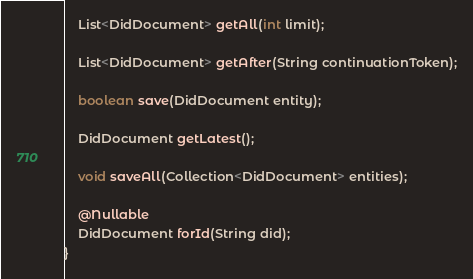<code> <loc_0><loc_0><loc_500><loc_500><_Java_>    List<DidDocument> getAll(int limit);

    List<DidDocument> getAfter(String continuationToken);

    boolean save(DidDocument entity);

    DidDocument getLatest();

    void saveAll(Collection<DidDocument> entities);

    @Nullable
    DidDocument forId(String did);
}
</code> 